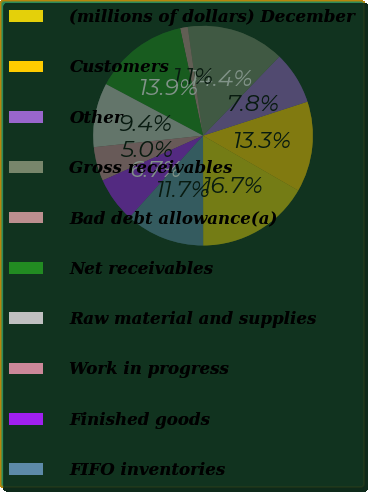Convert chart to OTSL. <chart><loc_0><loc_0><loc_500><loc_500><pie_chart><fcel>(millions of dollars) December<fcel>Customers<fcel>Other<fcel>Gross receivables<fcel>Bad debt allowance(a)<fcel>Net receivables<fcel>Raw material and supplies<fcel>Work in progress<fcel>Finished goods<fcel>FIFO inventories<nl><fcel>16.66%<fcel>13.33%<fcel>7.78%<fcel>14.44%<fcel>1.12%<fcel>13.89%<fcel>9.44%<fcel>5.0%<fcel>6.67%<fcel>11.67%<nl></chart> 